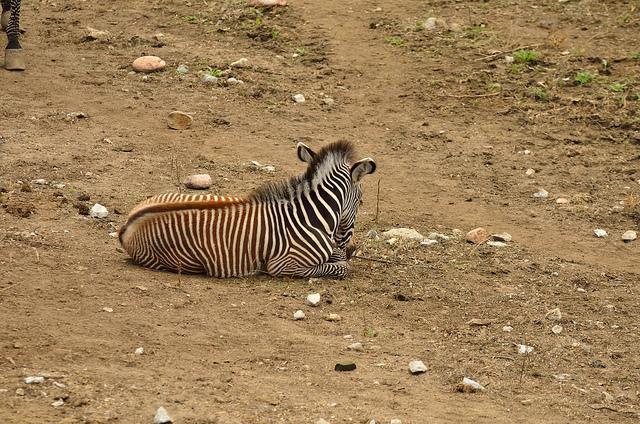How many glass bottles are on the ledge behind the stove?
Give a very brief answer. 0. 